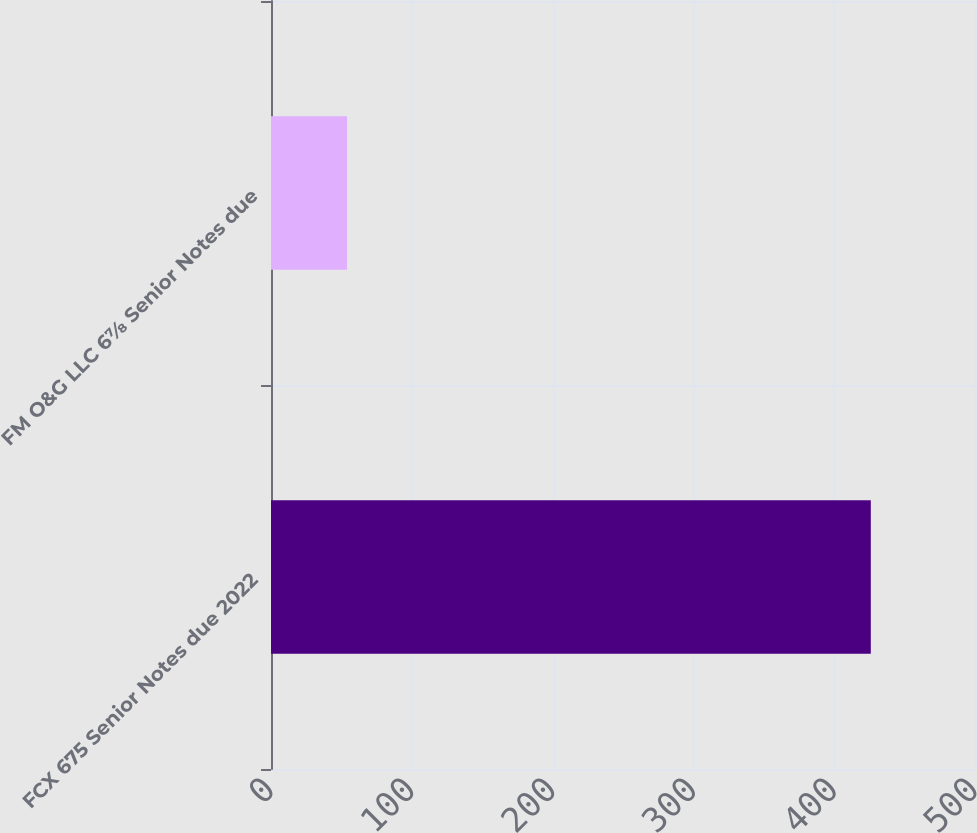<chart> <loc_0><loc_0><loc_500><loc_500><bar_chart><fcel>FCX 675 Senior Notes due 2022<fcel>FM O&G LLC 6⅞ Senior Notes due<nl><fcel>426<fcel>54<nl></chart> 